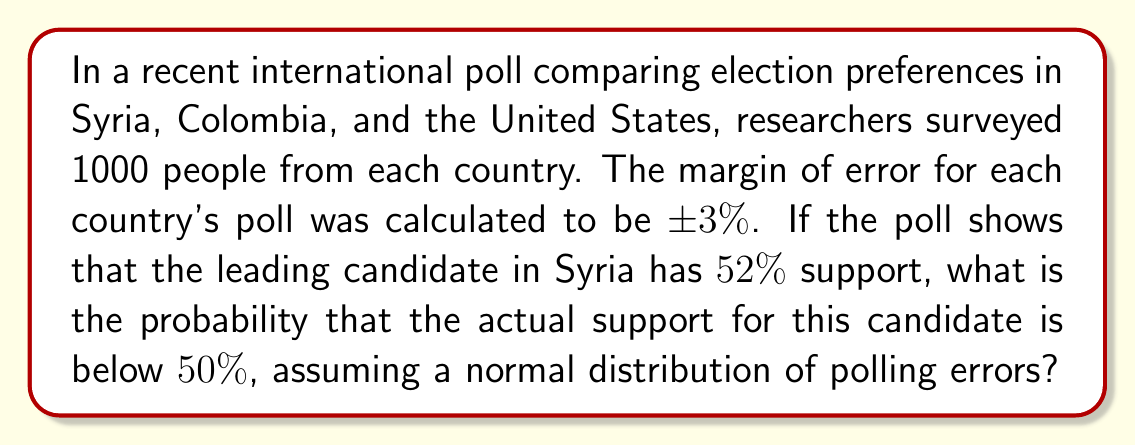Teach me how to tackle this problem. To solve this problem, we need to follow these steps:

1) First, we need to understand what the margin of error means. A ±3% margin of error with 95% confidence means that there's a 95% chance that the true population parameter is within 3 percentage points of the sample statistic.

2) We can use this to determine the standard error (SE) of the poll:
   $$ SE = \frac{3\%}{1.96} \approx 1.53\% $$
   This is because 1.96 is the z-score for a 95% confidence interval in a normal distribution.

3) Now, we want to find the probability that the actual support is below 50%, given that the poll shows 52% support. We can calculate this using the z-score:

   $$ z = \frac{50\% - 52\%}{1.53\%} \approx -1.31 $$

4) This z-score represents how many standard deviations 50% is from the polled result of 52%.

5) To find the probability, we need to look up the area to the left of -1.31 in a standard normal distribution table, or use a calculator function for the cumulative normal distribution.

6) Using a standard normal distribution calculator, we find:
   $$ P(Z < -1.31) \approx 0.0951 $$

Therefore, there is approximately a 9.51% chance that the actual support is below 50%.
Answer: 0.0951 or 9.51% 